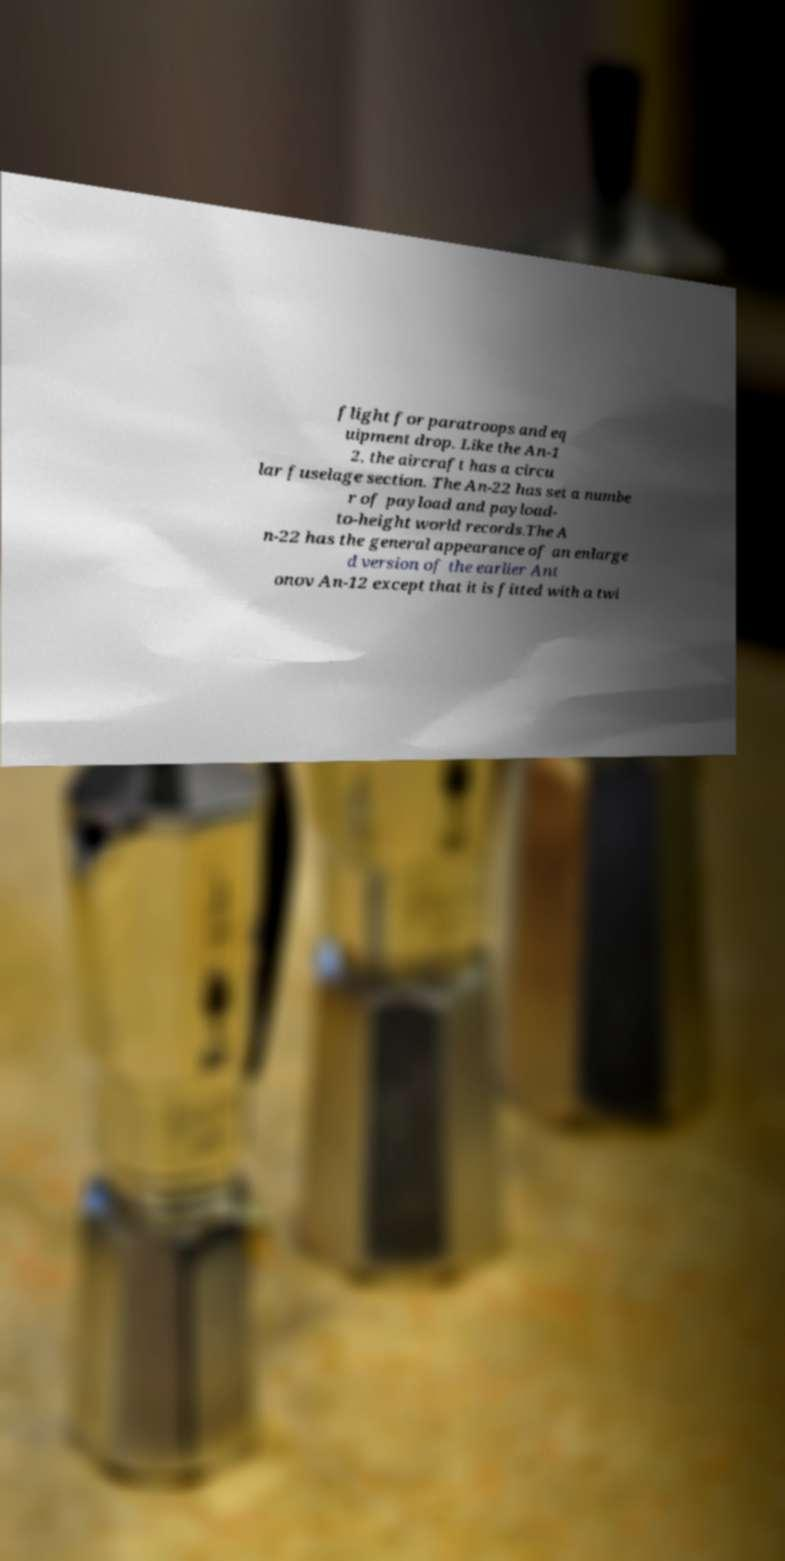Can you read and provide the text displayed in the image?This photo seems to have some interesting text. Can you extract and type it out for me? flight for paratroops and eq uipment drop. Like the An-1 2, the aircraft has a circu lar fuselage section. The An-22 has set a numbe r of payload and payload- to-height world records.The A n-22 has the general appearance of an enlarge d version of the earlier Ant onov An-12 except that it is fitted with a twi 